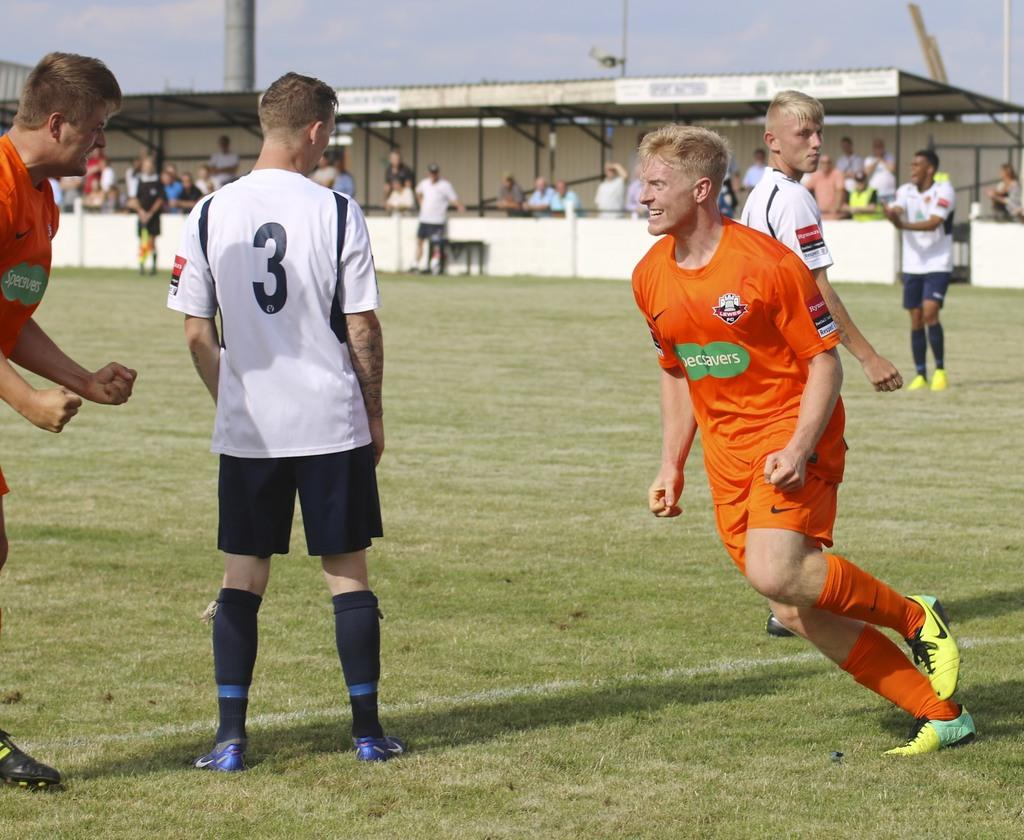<image>
Describe the image concisely. An athlete wearing a shirt with the number 3 stands on a field with his back to the game while players from the opposing team in orange smile. 